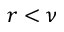Convert formula to latex. <formula><loc_0><loc_0><loc_500><loc_500>r < \nu</formula> 